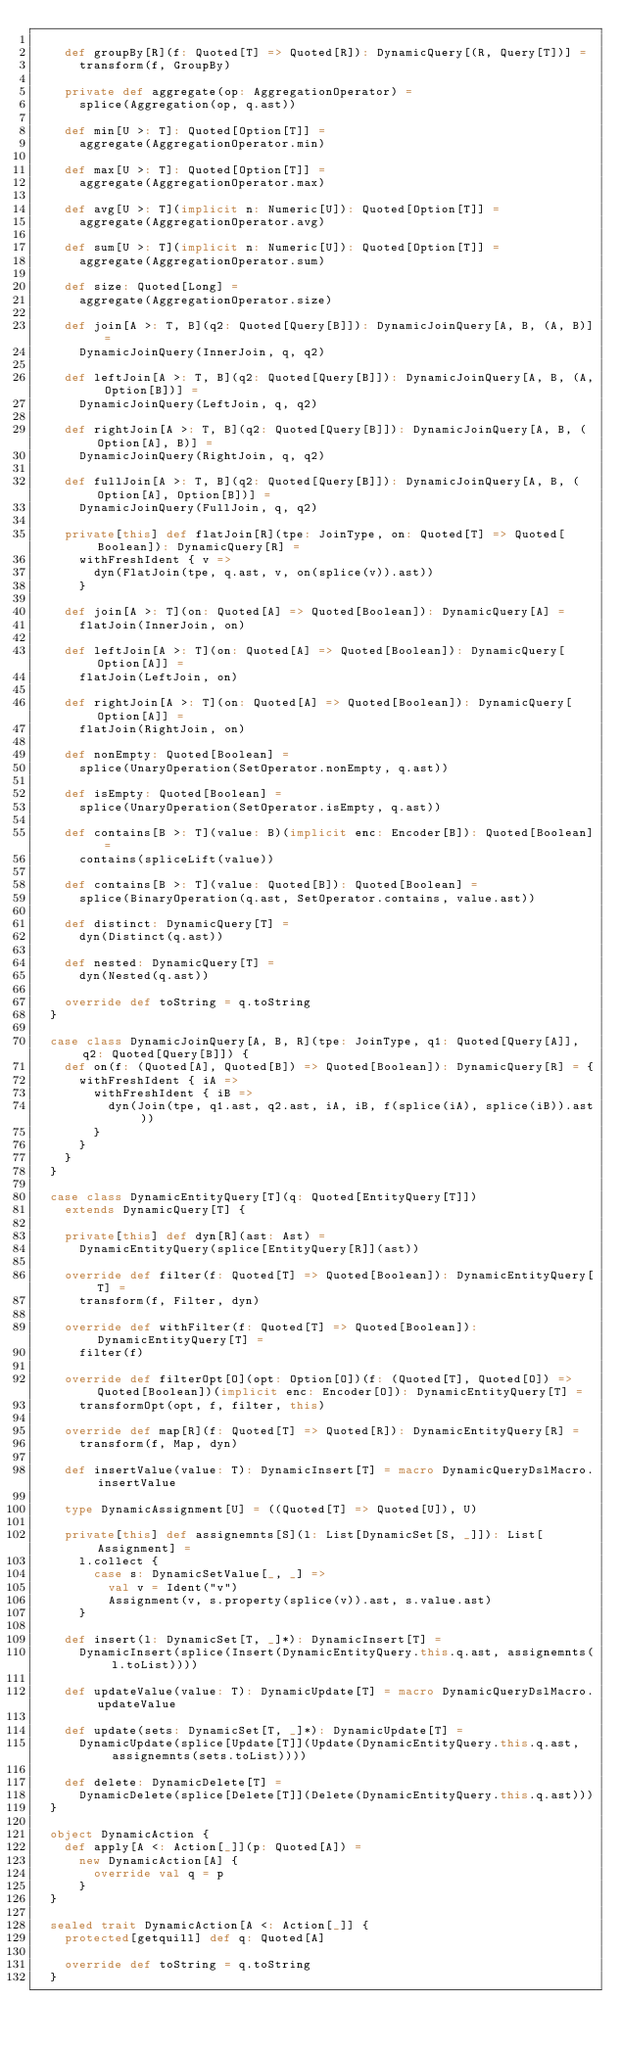<code> <loc_0><loc_0><loc_500><loc_500><_Scala_>
    def groupBy[R](f: Quoted[T] => Quoted[R]): DynamicQuery[(R, Query[T])] =
      transform(f, GroupBy)

    private def aggregate(op: AggregationOperator) =
      splice(Aggregation(op, q.ast))

    def min[U >: T]: Quoted[Option[T]] =
      aggregate(AggregationOperator.min)

    def max[U >: T]: Quoted[Option[T]] =
      aggregate(AggregationOperator.max)

    def avg[U >: T](implicit n: Numeric[U]): Quoted[Option[T]] =
      aggregate(AggregationOperator.avg)

    def sum[U >: T](implicit n: Numeric[U]): Quoted[Option[T]] =
      aggregate(AggregationOperator.sum)

    def size: Quoted[Long] =
      aggregate(AggregationOperator.size)

    def join[A >: T, B](q2: Quoted[Query[B]]): DynamicJoinQuery[A, B, (A, B)] =
      DynamicJoinQuery(InnerJoin, q, q2)

    def leftJoin[A >: T, B](q2: Quoted[Query[B]]): DynamicJoinQuery[A, B, (A, Option[B])] =
      DynamicJoinQuery(LeftJoin, q, q2)

    def rightJoin[A >: T, B](q2: Quoted[Query[B]]): DynamicJoinQuery[A, B, (Option[A], B)] =
      DynamicJoinQuery(RightJoin, q, q2)

    def fullJoin[A >: T, B](q2: Quoted[Query[B]]): DynamicJoinQuery[A, B, (Option[A], Option[B])] =
      DynamicJoinQuery(FullJoin, q, q2)

    private[this] def flatJoin[R](tpe: JoinType, on: Quoted[T] => Quoted[Boolean]): DynamicQuery[R] =
      withFreshIdent { v =>
        dyn(FlatJoin(tpe, q.ast, v, on(splice(v)).ast))
      }

    def join[A >: T](on: Quoted[A] => Quoted[Boolean]): DynamicQuery[A] =
      flatJoin(InnerJoin, on)

    def leftJoin[A >: T](on: Quoted[A] => Quoted[Boolean]): DynamicQuery[Option[A]] =
      flatJoin(LeftJoin, on)

    def rightJoin[A >: T](on: Quoted[A] => Quoted[Boolean]): DynamicQuery[Option[A]] =
      flatJoin(RightJoin, on)

    def nonEmpty: Quoted[Boolean] =
      splice(UnaryOperation(SetOperator.nonEmpty, q.ast))

    def isEmpty: Quoted[Boolean] =
      splice(UnaryOperation(SetOperator.isEmpty, q.ast))

    def contains[B >: T](value: B)(implicit enc: Encoder[B]): Quoted[Boolean] =
      contains(spliceLift(value))

    def contains[B >: T](value: Quoted[B]): Quoted[Boolean] =
      splice(BinaryOperation(q.ast, SetOperator.contains, value.ast))

    def distinct: DynamicQuery[T] =
      dyn(Distinct(q.ast))

    def nested: DynamicQuery[T] =
      dyn(Nested(q.ast))

    override def toString = q.toString
  }

  case class DynamicJoinQuery[A, B, R](tpe: JoinType, q1: Quoted[Query[A]], q2: Quoted[Query[B]]) {
    def on(f: (Quoted[A], Quoted[B]) => Quoted[Boolean]): DynamicQuery[R] = {
      withFreshIdent { iA =>
        withFreshIdent { iB =>
          dyn(Join(tpe, q1.ast, q2.ast, iA, iB, f(splice(iA), splice(iB)).ast))
        }
      }
    }
  }

  case class DynamicEntityQuery[T](q: Quoted[EntityQuery[T]])
    extends DynamicQuery[T] {

    private[this] def dyn[R](ast: Ast) =
      DynamicEntityQuery(splice[EntityQuery[R]](ast))

    override def filter(f: Quoted[T] => Quoted[Boolean]): DynamicEntityQuery[T] =
      transform(f, Filter, dyn)

    override def withFilter(f: Quoted[T] => Quoted[Boolean]): DynamicEntityQuery[T] =
      filter(f)

    override def filterOpt[O](opt: Option[O])(f: (Quoted[T], Quoted[O]) => Quoted[Boolean])(implicit enc: Encoder[O]): DynamicEntityQuery[T] =
      transformOpt(opt, f, filter, this)

    override def map[R](f: Quoted[T] => Quoted[R]): DynamicEntityQuery[R] =
      transform(f, Map, dyn)

    def insertValue(value: T): DynamicInsert[T] = macro DynamicQueryDslMacro.insertValue

    type DynamicAssignment[U] = ((Quoted[T] => Quoted[U]), U)

    private[this] def assignemnts[S](l: List[DynamicSet[S, _]]): List[Assignment] =
      l.collect {
        case s: DynamicSetValue[_, _] =>
          val v = Ident("v")
          Assignment(v, s.property(splice(v)).ast, s.value.ast)
      }

    def insert(l: DynamicSet[T, _]*): DynamicInsert[T] =
      DynamicInsert(splice(Insert(DynamicEntityQuery.this.q.ast, assignemnts(l.toList))))

    def updateValue(value: T): DynamicUpdate[T] = macro DynamicQueryDslMacro.updateValue

    def update(sets: DynamicSet[T, _]*): DynamicUpdate[T] =
      DynamicUpdate(splice[Update[T]](Update(DynamicEntityQuery.this.q.ast, assignemnts(sets.toList))))

    def delete: DynamicDelete[T] =
      DynamicDelete(splice[Delete[T]](Delete(DynamicEntityQuery.this.q.ast)))
  }

  object DynamicAction {
    def apply[A <: Action[_]](p: Quoted[A]) =
      new DynamicAction[A] {
        override val q = p
      }
  }

  sealed trait DynamicAction[A <: Action[_]] {
    protected[getquill] def q: Quoted[A]

    override def toString = q.toString
  }
</code> 